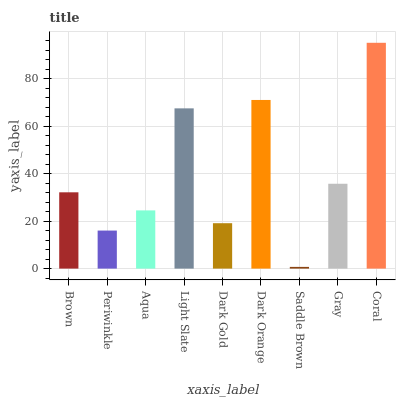Is Saddle Brown the minimum?
Answer yes or no. Yes. Is Coral the maximum?
Answer yes or no. Yes. Is Periwinkle the minimum?
Answer yes or no. No. Is Periwinkle the maximum?
Answer yes or no. No. Is Brown greater than Periwinkle?
Answer yes or no. Yes. Is Periwinkle less than Brown?
Answer yes or no. Yes. Is Periwinkle greater than Brown?
Answer yes or no. No. Is Brown less than Periwinkle?
Answer yes or no. No. Is Brown the high median?
Answer yes or no. Yes. Is Brown the low median?
Answer yes or no. Yes. Is Dark Orange the high median?
Answer yes or no. No. Is Coral the low median?
Answer yes or no. No. 